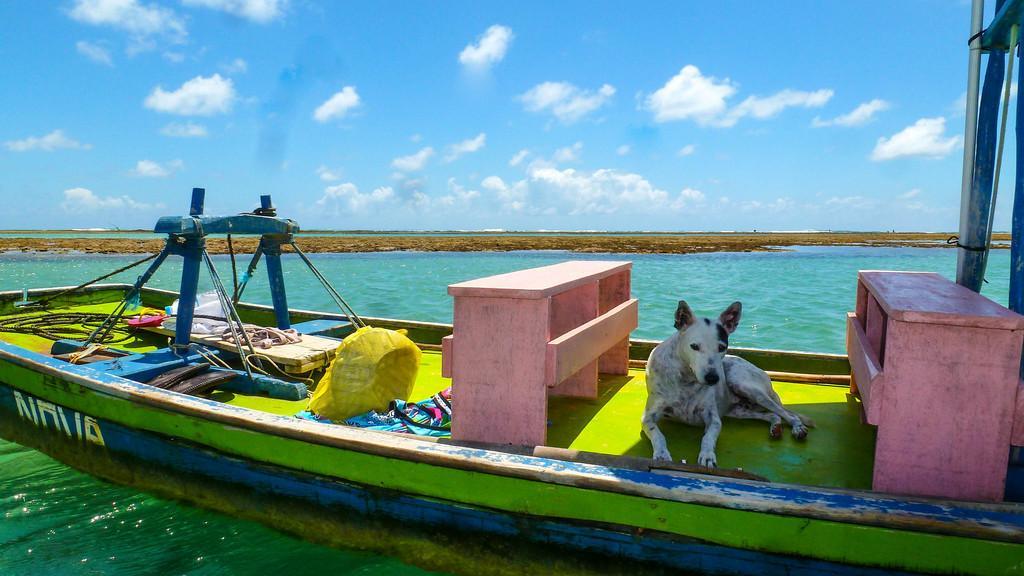Describe this image in one or two sentences. On the right side, there is a dog on the light green color surface of a boat, on which there are wooden benches and other objects. This boat is on the water. In the background, there is dry land and there are clouds in the blue sky. 